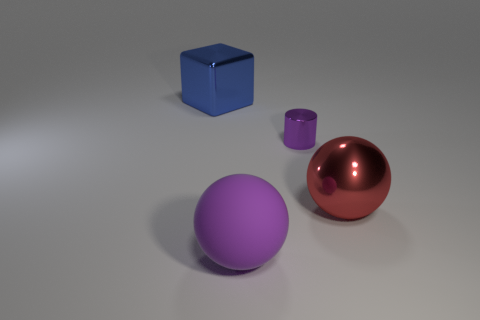How many large objects are to the left of the purple shiny cylinder and in front of the purple metal cylinder?
Your answer should be compact. 1. How many other big objects are the same shape as the big purple rubber thing?
Offer a terse response. 1. Do the large red ball and the tiny purple object have the same material?
Give a very brief answer. Yes. What is the shape of the purple thing that is in front of the big metallic object that is right of the tiny purple cylinder?
Offer a terse response. Sphere. There is a big metallic thing that is on the right side of the big block; how many small purple shiny cylinders are behind it?
Give a very brief answer. 1. The big object that is in front of the blue shiny cube and on the left side of the big red thing is made of what material?
Make the answer very short. Rubber. What is the shape of the blue object that is the same size as the red metallic object?
Ensure brevity in your answer.  Cube. There is a large metal object left of the large shiny object in front of the shiny object that is behind the purple metallic object; what color is it?
Your answer should be compact. Blue. How many objects are shiny objects in front of the large blue thing or red objects?
Offer a terse response. 2. There is a cube that is the same size as the rubber thing; what is it made of?
Provide a short and direct response. Metal. 